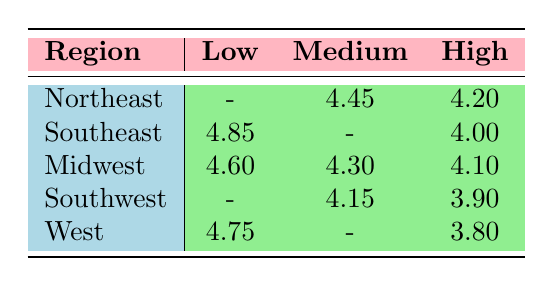What is the customer satisfaction rating for low complexity systems in the Northeast region? The Northeast region has no entries for low complexity systems in the table, so there is no customer satisfaction rating available.
Answer: No rating Which region has the highest customer satisfaction rating for medium complexity systems? In the table, the Northeast has a rating of 4.45 for medium complexity systems, which is the highest rating compared to other regions.
Answer: Northeast What is the average customer satisfaction rating for high complexity systems across all regions? The high complexity ratings are 4.20 (Northeast), 4.00 (Southeast), 4.10 (Midwest), 3.90 (Southwest), and 3.80 (West). The average is calculated as (4.20 + 4.00 + 4.10 + 3.90 + 3.80) / 5 = 4.02.
Answer: 4.02 Is there any region that does not have a rating for medium complexity systems? Yes, both the Southeast and the West regions do not have a rating for medium complexity systems.
Answer: Yes Which region shows the most consistent customer satisfaction ratings across different system complexities? To determine consistency, we look at the range of ratings in each region. The Midwest has ratings of 4.60 (low), 4.30 (medium), and 4.10 (high), showing a narrower range compared to other regions.
Answer: Midwest What is the difference in customer satisfaction ratings between the highest and lowest rated systems in the Southwest region? In the Southwest, the high complexity system rating is 3.90, and the medium complexity system rating is 4.15. The difference is 4.15 - 3.90 = 0.25.
Answer: 0.25 Which company in the West region has the lowest customer satisfaction rating for smart home systems? TechnoLiving has the lowest customer satisfaction rating in the West with a score of 3.80 for high complexity systems.
Answer: TechnoLiving What is the customer satisfaction rating for low complexity systems in the Southeast region? In the Southeast, the low complexity system rating is 4.85, which is the only one in that category for that region.
Answer: 4.85 